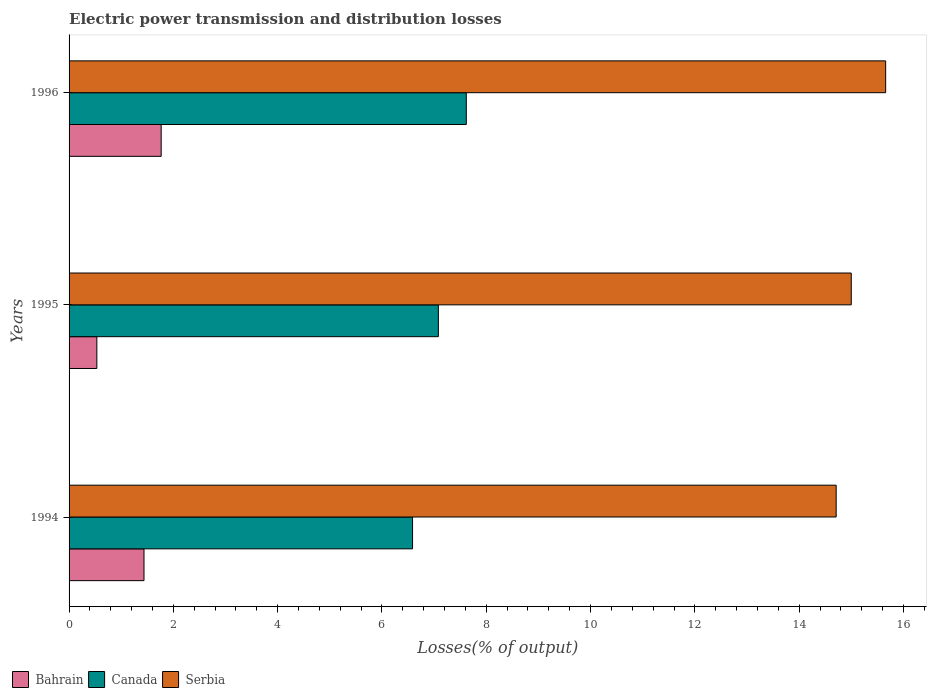How many different coloured bars are there?
Keep it short and to the point. 3. How many groups of bars are there?
Your answer should be compact. 3. Are the number of bars per tick equal to the number of legend labels?
Keep it short and to the point. Yes. Are the number of bars on each tick of the Y-axis equal?
Offer a very short reply. Yes. How many bars are there on the 1st tick from the top?
Keep it short and to the point. 3. How many bars are there on the 1st tick from the bottom?
Provide a succinct answer. 3. What is the label of the 1st group of bars from the top?
Offer a terse response. 1996. In how many cases, is the number of bars for a given year not equal to the number of legend labels?
Ensure brevity in your answer.  0. What is the electric power transmission and distribution losses in Serbia in 1996?
Ensure brevity in your answer.  15.66. Across all years, what is the maximum electric power transmission and distribution losses in Bahrain?
Keep it short and to the point. 1.77. Across all years, what is the minimum electric power transmission and distribution losses in Bahrain?
Make the answer very short. 0.53. In which year was the electric power transmission and distribution losses in Bahrain maximum?
Offer a very short reply. 1996. What is the total electric power transmission and distribution losses in Serbia in the graph?
Make the answer very short. 45.37. What is the difference between the electric power transmission and distribution losses in Canada in 1995 and that in 1996?
Provide a short and direct response. -0.54. What is the difference between the electric power transmission and distribution losses in Canada in 1994 and the electric power transmission and distribution losses in Serbia in 1996?
Your response must be concise. -9.07. What is the average electric power transmission and distribution losses in Bahrain per year?
Your answer should be compact. 1.25. In the year 1994, what is the difference between the electric power transmission and distribution losses in Serbia and electric power transmission and distribution losses in Bahrain?
Provide a short and direct response. 13.27. In how many years, is the electric power transmission and distribution losses in Serbia greater than 9.2 %?
Provide a succinct answer. 3. What is the ratio of the electric power transmission and distribution losses in Canada in 1995 to that in 1996?
Offer a terse response. 0.93. Is the difference between the electric power transmission and distribution losses in Serbia in 1994 and 1995 greater than the difference between the electric power transmission and distribution losses in Bahrain in 1994 and 1995?
Your response must be concise. No. What is the difference between the highest and the second highest electric power transmission and distribution losses in Bahrain?
Your response must be concise. 0.33. What is the difference between the highest and the lowest electric power transmission and distribution losses in Canada?
Your answer should be very brief. 1.03. In how many years, is the electric power transmission and distribution losses in Bahrain greater than the average electric power transmission and distribution losses in Bahrain taken over all years?
Give a very brief answer. 2. What does the 3rd bar from the top in 1996 represents?
Make the answer very short. Bahrain. What does the 3rd bar from the bottom in 1994 represents?
Your answer should be very brief. Serbia. Is it the case that in every year, the sum of the electric power transmission and distribution losses in Bahrain and electric power transmission and distribution losses in Canada is greater than the electric power transmission and distribution losses in Serbia?
Your answer should be compact. No. Are all the bars in the graph horizontal?
Offer a very short reply. Yes. What is the difference between two consecutive major ticks on the X-axis?
Your answer should be compact. 2. Does the graph contain grids?
Provide a succinct answer. No. How are the legend labels stacked?
Your answer should be very brief. Horizontal. What is the title of the graph?
Offer a very short reply. Electric power transmission and distribution losses. Does "Least developed countries" appear as one of the legend labels in the graph?
Your response must be concise. No. What is the label or title of the X-axis?
Keep it short and to the point. Losses(% of output). What is the label or title of the Y-axis?
Make the answer very short. Years. What is the Losses(% of output) of Bahrain in 1994?
Your answer should be very brief. 1.44. What is the Losses(% of output) of Canada in 1994?
Provide a succinct answer. 6.59. What is the Losses(% of output) in Serbia in 1994?
Your response must be concise. 14.71. What is the Losses(% of output) in Bahrain in 1995?
Ensure brevity in your answer.  0.53. What is the Losses(% of output) in Canada in 1995?
Ensure brevity in your answer.  7.08. What is the Losses(% of output) in Serbia in 1995?
Your answer should be compact. 15. What is the Losses(% of output) in Bahrain in 1996?
Your answer should be compact. 1.77. What is the Losses(% of output) in Canada in 1996?
Provide a short and direct response. 7.62. What is the Losses(% of output) of Serbia in 1996?
Your response must be concise. 15.66. Across all years, what is the maximum Losses(% of output) in Bahrain?
Your response must be concise. 1.77. Across all years, what is the maximum Losses(% of output) of Canada?
Your answer should be compact. 7.62. Across all years, what is the maximum Losses(% of output) of Serbia?
Your answer should be very brief. 15.66. Across all years, what is the minimum Losses(% of output) in Bahrain?
Provide a short and direct response. 0.53. Across all years, what is the minimum Losses(% of output) of Canada?
Provide a succinct answer. 6.59. Across all years, what is the minimum Losses(% of output) in Serbia?
Keep it short and to the point. 14.71. What is the total Losses(% of output) of Bahrain in the graph?
Offer a terse response. 3.74. What is the total Losses(% of output) of Canada in the graph?
Offer a terse response. 21.29. What is the total Losses(% of output) of Serbia in the graph?
Provide a short and direct response. 45.37. What is the difference between the Losses(% of output) of Bahrain in 1994 and that in 1995?
Your answer should be very brief. 0.9. What is the difference between the Losses(% of output) in Canada in 1994 and that in 1995?
Your response must be concise. -0.5. What is the difference between the Losses(% of output) in Serbia in 1994 and that in 1995?
Ensure brevity in your answer.  -0.29. What is the difference between the Losses(% of output) of Bahrain in 1994 and that in 1996?
Provide a succinct answer. -0.33. What is the difference between the Losses(% of output) of Canada in 1994 and that in 1996?
Give a very brief answer. -1.03. What is the difference between the Losses(% of output) of Serbia in 1994 and that in 1996?
Offer a terse response. -0.95. What is the difference between the Losses(% of output) of Bahrain in 1995 and that in 1996?
Keep it short and to the point. -1.23. What is the difference between the Losses(% of output) in Canada in 1995 and that in 1996?
Ensure brevity in your answer.  -0.54. What is the difference between the Losses(% of output) of Serbia in 1995 and that in 1996?
Your answer should be compact. -0.66. What is the difference between the Losses(% of output) in Bahrain in 1994 and the Losses(% of output) in Canada in 1995?
Offer a very short reply. -5.64. What is the difference between the Losses(% of output) in Bahrain in 1994 and the Losses(% of output) in Serbia in 1995?
Make the answer very short. -13.56. What is the difference between the Losses(% of output) of Canada in 1994 and the Losses(% of output) of Serbia in 1995?
Offer a terse response. -8.41. What is the difference between the Losses(% of output) in Bahrain in 1994 and the Losses(% of output) in Canada in 1996?
Ensure brevity in your answer.  -6.18. What is the difference between the Losses(% of output) in Bahrain in 1994 and the Losses(% of output) in Serbia in 1996?
Your response must be concise. -14.22. What is the difference between the Losses(% of output) in Canada in 1994 and the Losses(% of output) in Serbia in 1996?
Your answer should be very brief. -9.07. What is the difference between the Losses(% of output) in Bahrain in 1995 and the Losses(% of output) in Canada in 1996?
Give a very brief answer. -7.08. What is the difference between the Losses(% of output) of Bahrain in 1995 and the Losses(% of output) of Serbia in 1996?
Provide a short and direct response. -15.13. What is the difference between the Losses(% of output) of Canada in 1995 and the Losses(% of output) of Serbia in 1996?
Provide a short and direct response. -8.58. What is the average Losses(% of output) in Bahrain per year?
Your answer should be compact. 1.25. What is the average Losses(% of output) in Canada per year?
Provide a short and direct response. 7.09. What is the average Losses(% of output) of Serbia per year?
Provide a short and direct response. 15.12. In the year 1994, what is the difference between the Losses(% of output) in Bahrain and Losses(% of output) in Canada?
Your answer should be very brief. -5.15. In the year 1994, what is the difference between the Losses(% of output) in Bahrain and Losses(% of output) in Serbia?
Offer a very short reply. -13.27. In the year 1994, what is the difference between the Losses(% of output) in Canada and Losses(% of output) in Serbia?
Make the answer very short. -8.12. In the year 1995, what is the difference between the Losses(% of output) in Bahrain and Losses(% of output) in Canada?
Your answer should be very brief. -6.55. In the year 1995, what is the difference between the Losses(% of output) of Bahrain and Losses(% of output) of Serbia?
Ensure brevity in your answer.  -14.47. In the year 1995, what is the difference between the Losses(% of output) of Canada and Losses(% of output) of Serbia?
Ensure brevity in your answer.  -7.92. In the year 1996, what is the difference between the Losses(% of output) of Bahrain and Losses(% of output) of Canada?
Provide a short and direct response. -5.85. In the year 1996, what is the difference between the Losses(% of output) in Bahrain and Losses(% of output) in Serbia?
Offer a terse response. -13.89. In the year 1996, what is the difference between the Losses(% of output) of Canada and Losses(% of output) of Serbia?
Keep it short and to the point. -8.04. What is the ratio of the Losses(% of output) of Bahrain in 1994 to that in 1995?
Offer a very short reply. 2.7. What is the ratio of the Losses(% of output) of Canada in 1994 to that in 1995?
Keep it short and to the point. 0.93. What is the ratio of the Losses(% of output) in Serbia in 1994 to that in 1995?
Provide a succinct answer. 0.98. What is the ratio of the Losses(% of output) of Bahrain in 1994 to that in 1996?
Your answer should be compact. 0.81. What is the ratio of the Losses(% of output) of Canada in 1994 to that in 1996?
Give a very brief answer. 0.86. What is the ratio of the Losses(% of output) of Serbia in 1994 to that in 1996?
Offer a terse response. 0.94. What is the ratio of the Losses(% of output) in Bahrain in 1995 to that in 1996?
Offer a very short reply. 0.3. What is the ratio of the Losses(% of output) in Canada in 1995 to that in 1996?
Make the answer very short. 0.93. What is the ratio of the Losses(% of output) in Serbia in 1995 to that in 1996?
Offer a terse response. 0.96. What is the difference between the highest and the second highest Losses(% of output) of Bahrain?
Your answer should be very brief. 0.33. What is the difference between the highest and the second highest Losses(% of output) in Canada?
Give a very brief answer. 0.54. What is the difference between the highest and the second highest Losses(% of output) in Serbia?
Offer a very short reply. 0.66. What is the difference between the highest and the lowest Losses(% of output) in Bahrain?
Offer a terse response. 1.23. What is the difference between the highest and the lowest Losses(% of output) in Canada?
Offer a very short reply. 1.03. What is the difference between the highest and the lowest Losses(% of output) of Serbia?
Provide a succinct answer. 0.95. 